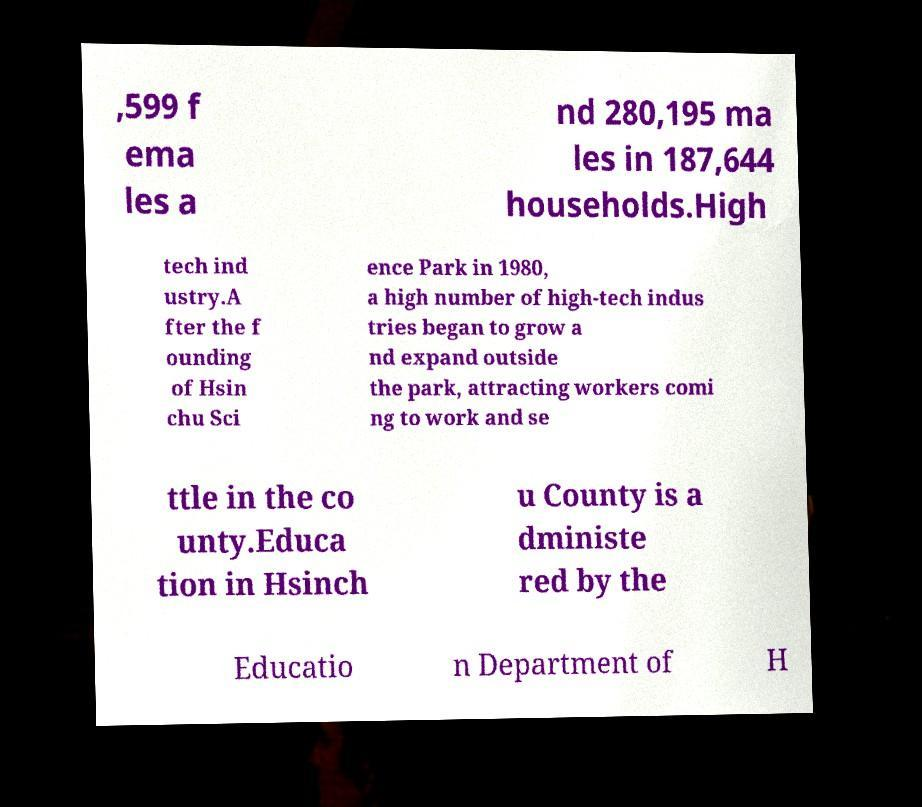Could you assist in decoding the text presented in this image and type it out clearly? ,599 f ema les a nd 280,195 ma les in 187,644 households.High tech ind ustry.A fter the f ounding of Hsin chu Sci ence Park in 1980, a high number of high-tech indus tries began to grow a nd expand outside the park, attracting workers comi ng to work and se ttle in the co unty.Educa tion in Hsinch u County is a dministe red by the Educatio n Department of H 